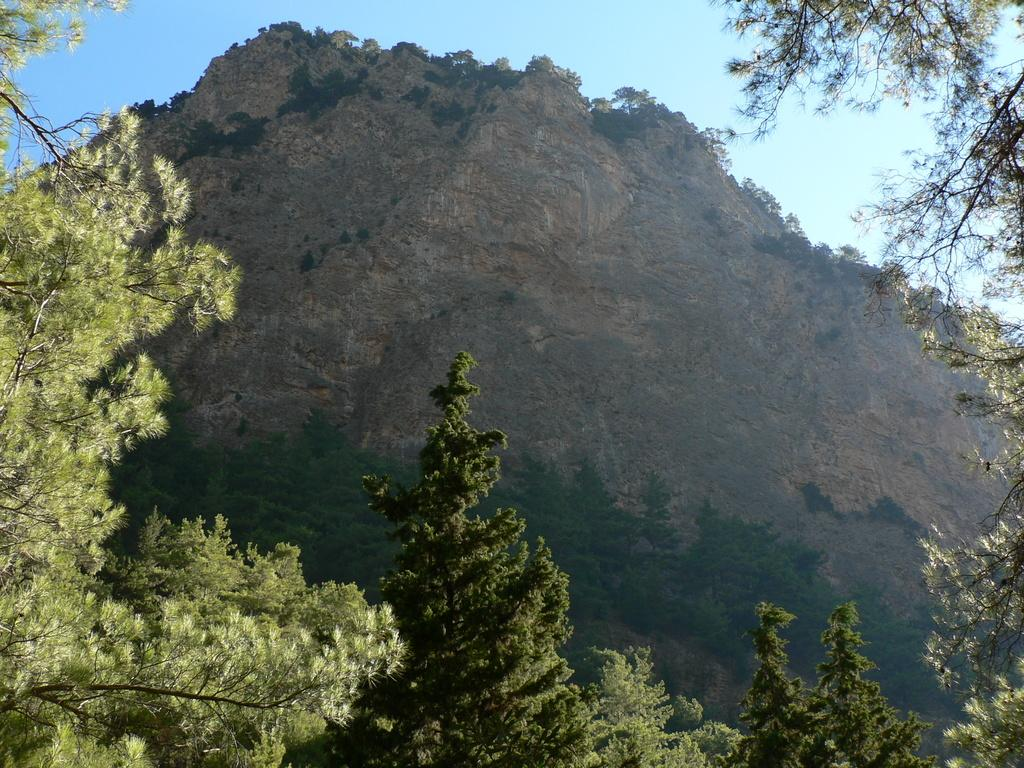What type of geographical feature is present in the image? There is a mountain in the image. What type of vegetation can be seen in the image? There are green trees in the image. What color is the sky in the image? The sky is blue in color. How many volleyballs are visible on the mountain in the image? There are no volleyballs present in the image; it features a mountain, green trees, and a blue sky. What type of hair can be seen on the trees in the image? Trees do not have hair; they have leaves and branches. 